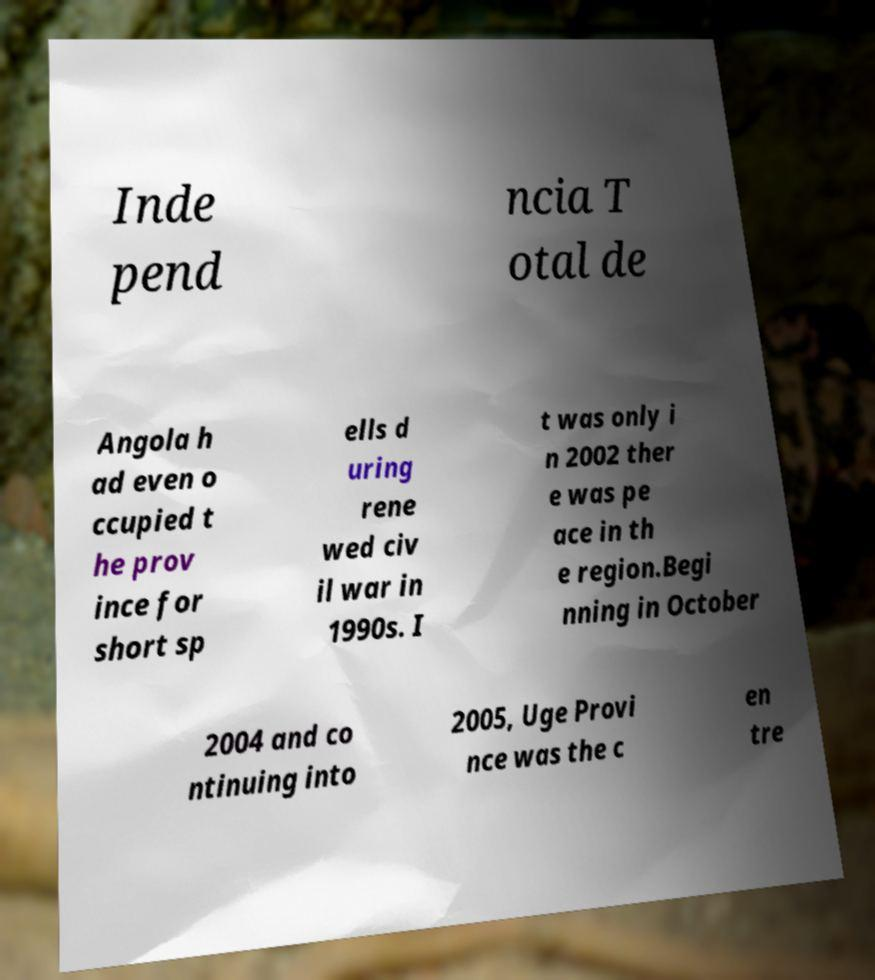Could you assist in decoding the text presented in this image and type it out clearly? Inde pend ncia T otal de Angola h ad even o ccupied t he prov ince for short sp ells d uring rene wed civ il war in 1990s. I t was only i n 2002 ther e was pe ace in th e region.Begi nning in October 2004 and co ntinuing into 2005, Uge Provi nce was the c en tre 